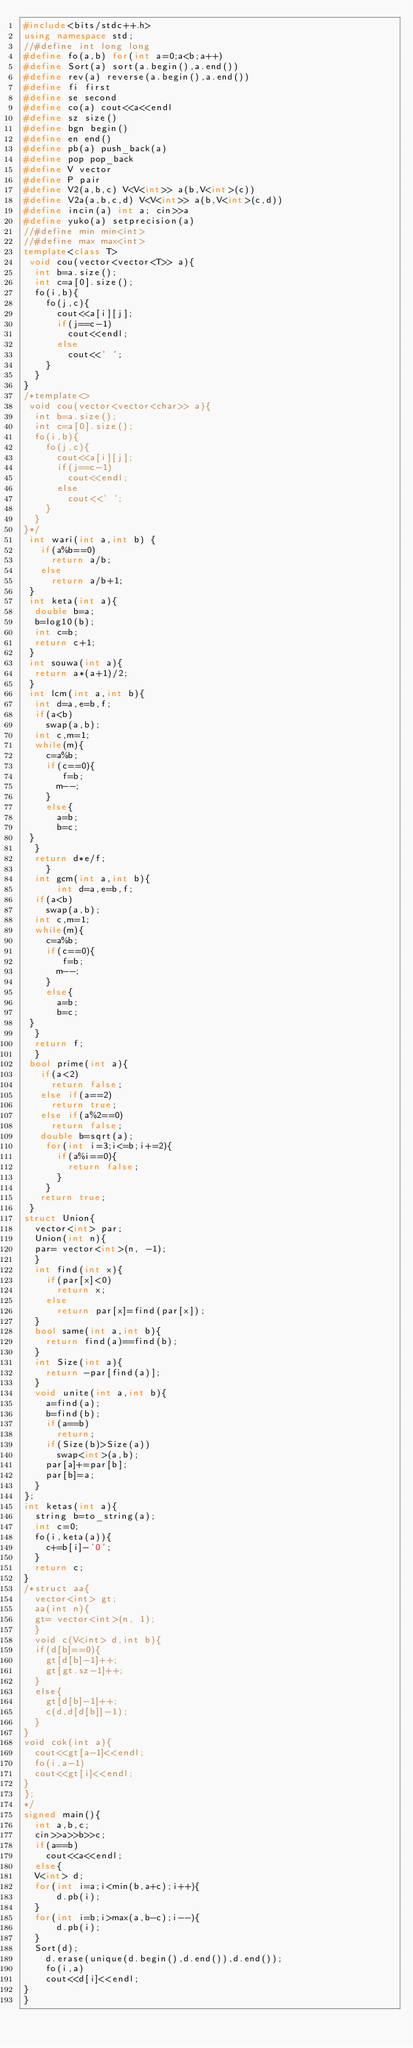<code> <loc_0><loc_0><loc_500><loc_500><_C++_>#include<bits/stdc++.h>
using namespace std;
//#define int long long
#define fo(a,b) for(int a=0;a<b;a++)
#define Sort(a) sort(a.begin(),a.end())
#define rev(a) reverse(a.begin(),a.end())
#define fi first
#define se second
#define co(a) cout<<a<<endl
#define sz size()
#define bgn begin()
#define en end()
#define pb(a) push_back(a)
#define pop pop_back
#define V vector
#define P pair
#define V2(a,b,c) V<V<int>> a(b,V<int>(c))
#define V2a(a,b,c,d) V<V<int>> a(b,V<int>(c,d))
#define incin(a) int a; cin>>a
#define yuko(a) setprecision(a)
//#define min min<int>
//#define max max<int>
template<class T>
 void cou(vector<vector<T>> a){
  int b=a.size();
  int c=a[0].size();
  fo(i,b){
    fo(j,c){
      cout<<a[i][j];
      if(j==c-1)
        cout<<endl;
      else
        cout<<' ';
    }
  }
}
/*template<>
 void cou(vector<vector<char>> a){
  int b=a.size();
  int c=a[0].size();
  fo(i,b){
    fo(j,c){
      cout<<a[i][j];
      if(j==c-1)
        cout<<endl;
      else
        cout<<' ';
    }
  }
}*/
 int wari(int a,int b) {
   if(a%b==0)
     return a/b;
   else
     return a/b+1;
 }
 int keta(int a){
  double b=a;
  b=log10(b);
  int c=b;
  return c+1;
 }
 int souwa(int a){
  return a*(a+1)/2;
 }
 int lcm(int a,int b){
  int d=a,e=b,f;
  if(a<b)
    swap(a,b);
  int c,m=1;
  while(m){
    c=a%b;
    if(c==0){
       f=b;
      m--;
    }
    else{
      a=b;
      b=c;
 }
  }
  return d*e/f;
    }
  int gcm(int a,int b){
      int d=a,e=b,f;
  if(a<b)
    swap(a,b);
  int c,m=1;
  while(m){
    c=a%b;
    if(c==0){
       f=b;
      m--;
    }
    else{
      a=b;
      b=c;
 }
  }
  return f;
  }
 bool prime(int a){
   if(a<2)
     return false;
   else if(a==2)
     return true;
   else if(a%2==0)
     return false;
   double b=sqrt(a);
    for(int i=3;i<=b;i+=2){
      if(a%i==0){
        return false;
      }
    }
   return true;
 }
struct Union{
  vector<int> par;
  Union(int n){
	par= vector<int>(n, -1);
  }
  int find(int x){
    if(par[x]<0)
      return x;
    else
      return par[x]=find(par[x]);
  }
  bool same(int a,int b){
    return find(a)==find(b);
  }
  int Size(int a){
    return -par[find(a)];
  }
  void unite(int a,int b){
    a=find(a);
    b=find(b);
    if(a==b)
      return;
    if(Size(b)>Size(a))
      swap<int>(a,b);
    par[a]+=par[b];
    par[b]=a;
  }
};
int ketas(int a){
  string b=to_string(a);
  int c=0;
  fo(i,keta(a)){
    c+=b[i]-'0';
  }
  return c;
}
/*struct aa{
	vector<int> gt;
  aa(int n){
	gt= vector<int>(n, 1);
  }
	void c(V<int> d,int b){
	if(d[b]==0){
		gt[d[b]-1]++;
		gt[gt.sz-1]++;
	}
	else{
		gt[d[b]-1]++;
		c(d,d[d[b]]-1);
	}
}
void cok(int a){
	cout<<gt[a-1]<<endl;
	fo(i,a-1)
	cout<<gt[i]<<endl;
}
};
*/
signed main(){
	int a,b,c;
	cin>>a>>b>>c;
	if(a==b)
		cout<<a<<endl;
	else{
	V<int> d;
	for(int i=a;i<min(b,a+c);i++){
			d.pb(i);
	}
	for(int i=b;i>max(a,b-c);i--){
			d.pb(i);
	}
	Sort(d);
    d.erase(unique(d.begin(),d.end()),d.end());
    fo(i,a)
    cout<<d[i]<<endl;
}
}</code> 